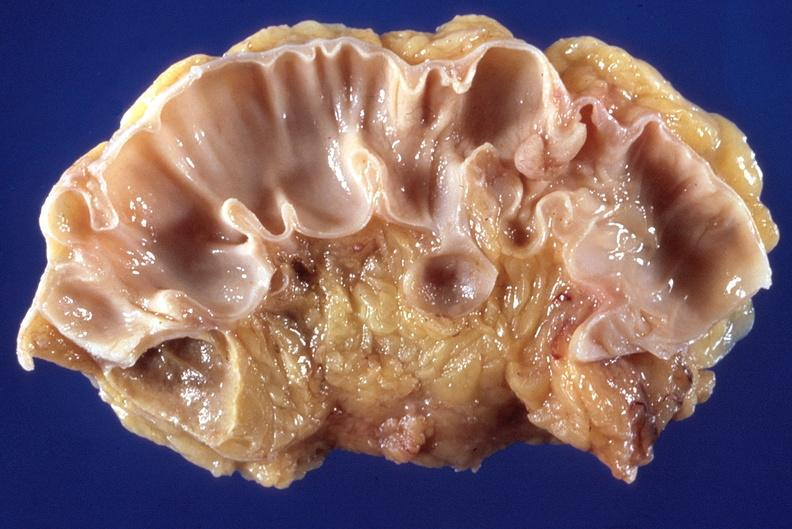what is present?
Answer the question using a single word or phrase. Gastrointestinal 